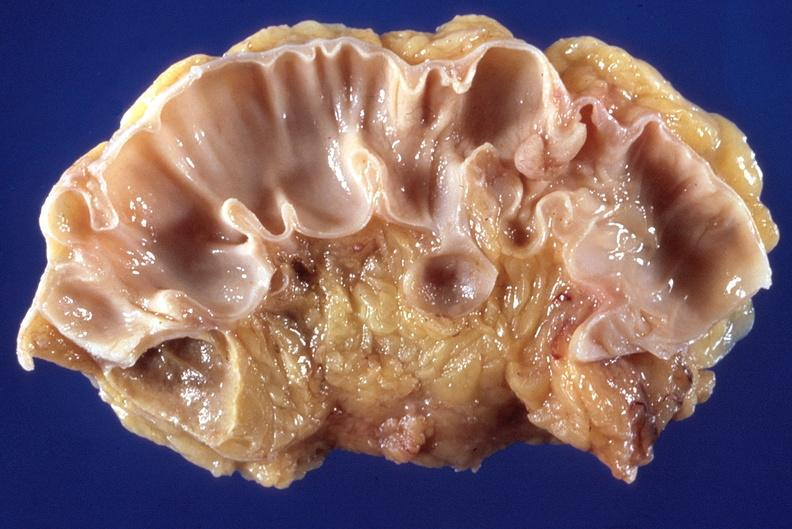what is present?
Answer the question using a single word or phrase. Gastrointestinal 